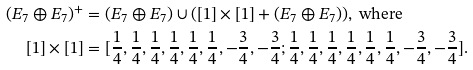Convert formula to latex. <formula><loc_0><loc_0><loc_500><loc_500>( E _ { 7 } \oplus E _ { 7 } ) ^ { + } & = ( E _ { 7 } \oplus E _ { 7 } ) \cup ( [ 1 ] \times [ 1 ] + ( E _ { 7 } \oplus E _ { 7 } ) ) , \text { where } \\ [ 1 ] \times [ 1 ] & = [ \frac { 1 } { 4 } , \frac { 1 } { 4 } , \frac { 1 } { 4 } , \frac { 1 } { 4 } , \frac { 1 } { 4 } , \frac { 1 } { 4 } , - \frac { 3 } { 4 } , - \frac { 3 } { 4 } ; \frac { 1 } { 4 } , \frac { 1 } { 4 } , \frac { 1 } { 4 } , \frac { 1 } { 4 } , \frac { 1 } { 4 } , \frac { 1 } { 4 } , - \frac { 3 } { 4 } , - \frac { 3 } { 4 } ] .</formula> 